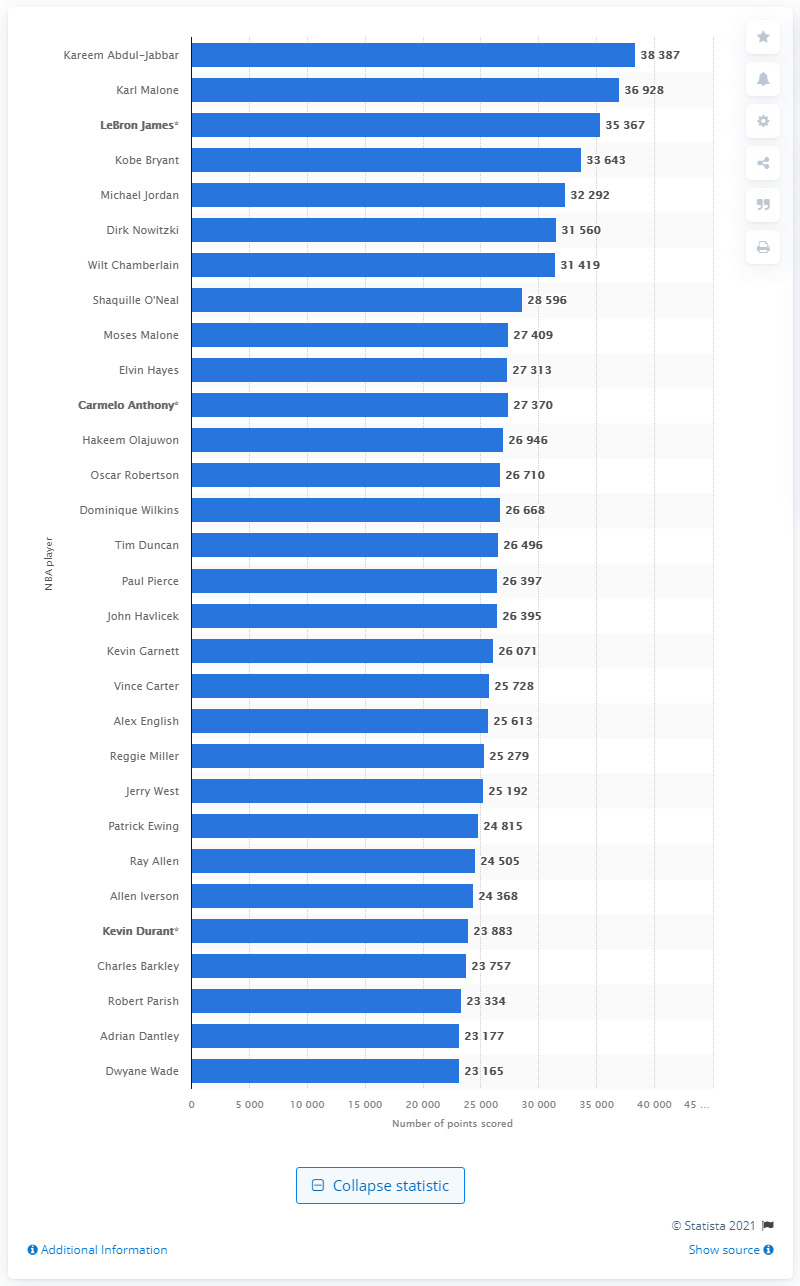Who is the NBA's current all-time leading scorer?
 Kareem Abdul-Jabbar 